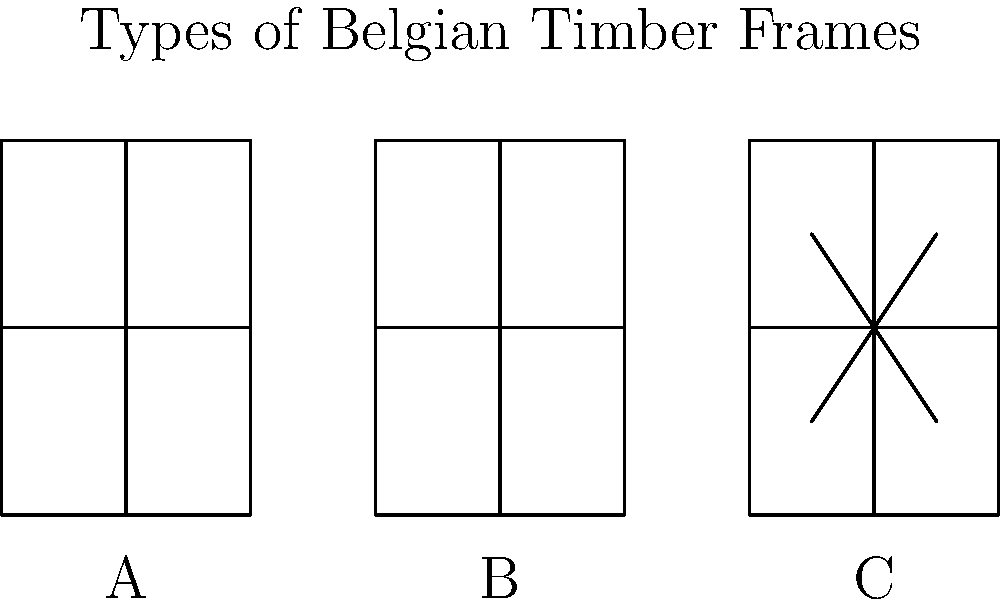Analyze the three types of Belgian timber-framed house structures shown in the diagram. Which type is most likely to provide the greatest structural stability and why? To determine which type of timber frame provides the greatest structural stability, we need to consider the design elements of each:

1. Type A: Basic frame
   - Vertical posts and horizontal beams
   - No diagonal bracing
   - Least stable of the three options

2. Type B: Cross-braced frame
   - Vertical posts and horizontal beams
   - Full-length diagonal cross braces
   - Significantly more stable than Type A due to triangulation

3. Type C: Partially braced frame
   - Vertical posts and horizontal beams
   - Partial diagonal braces in the central section
   - More stable than Type A, but less than Type B

The key factor in structural stability for timber frames is triangulation. Triangular shapes are inherently stable and resist deformation under load.

Type B provides the most extensive triangulation:
1. The full-length cross braces create multiple triangles within the frame.
2. These triangles distribute forces evenly throughout the structure.
3. The cross braces resist both compression and tension forces.
4. This design is highly effective against lateral forces (e.g., wind loads).

While Type C offers some triangulation, it is limited to the central section and doesn't provide the same level of overall stability as Type B.

Therefore, Type B is most likely to provide the greatest structural stability due to its comprehensive triangulation throughout the entire frame.
Answer: Type B (cross-braced frame) 